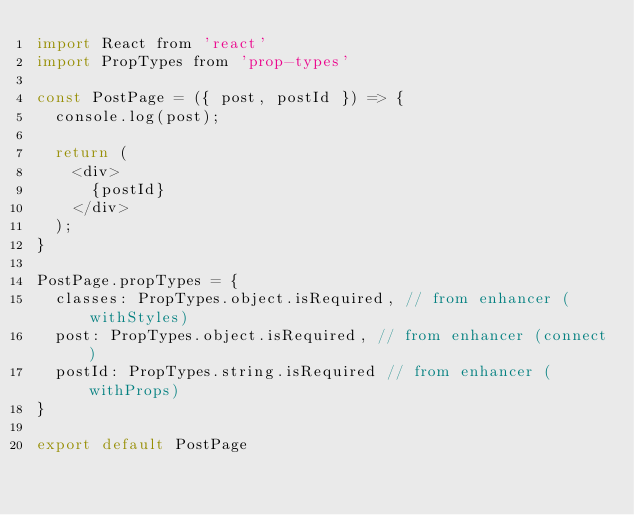<code> <loc_0><loc_0><loc_500><loc_500><_JavaScript_>import React from 'react'
import PropTypes from 'prop-types'

const PostPage = ({ post, postId }) => {
  console.log(post);

  return (
    <div>
      {postId}
    </div>
  );
}

PostPage.propTypes = {
  classes: PropTypes.object.isRequired, // from enhancer (withStyles)
  post: PropTypes.object.isRequired, // from enhancer (connect)
  postId: PropTypes.string.isRequired // from enhancer (withProps)
}

export default PostPage
</code> 